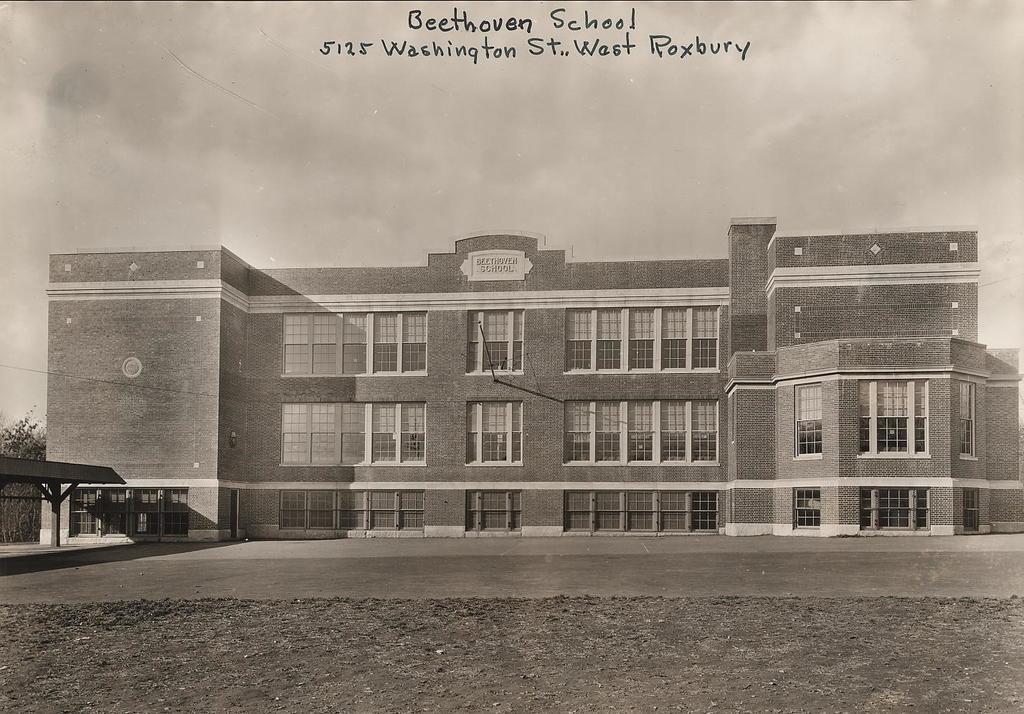Can you describe this image briefly? This picture consists of a building ,at the top I can see the sky and I can see a text visible at the top. And I can see trees visible on left side 